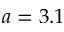<formula> <loc_0><loc_0><loc_500><loc_500>a = 3 . 1</formula> 